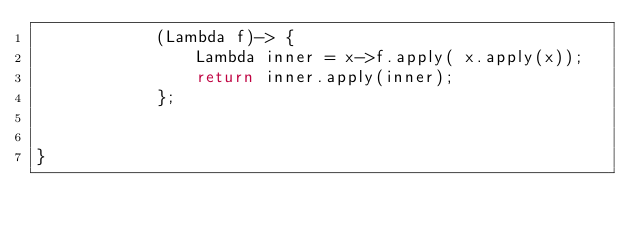<code> <loc_0><loc_0><loc_500><loc_500><_Java_>            (Lambda f)-> {
                Lambda inner = x->f.apply( x.apply(x));
                return inner.apply(inner);
            };


}
</code> 